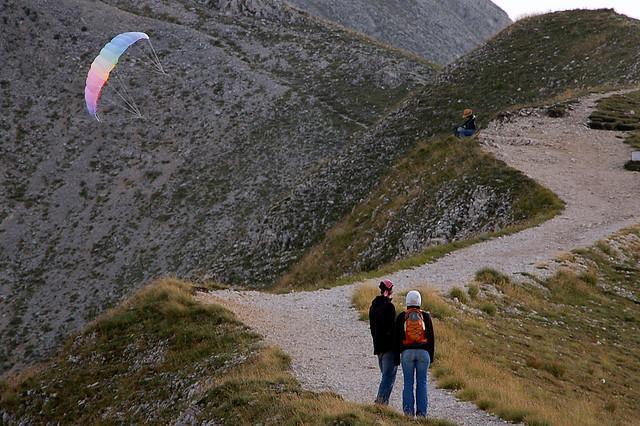How many people can you see?
Give a very brief answer. 2. How many red cars are there?
Give a very brief answer. 0. 